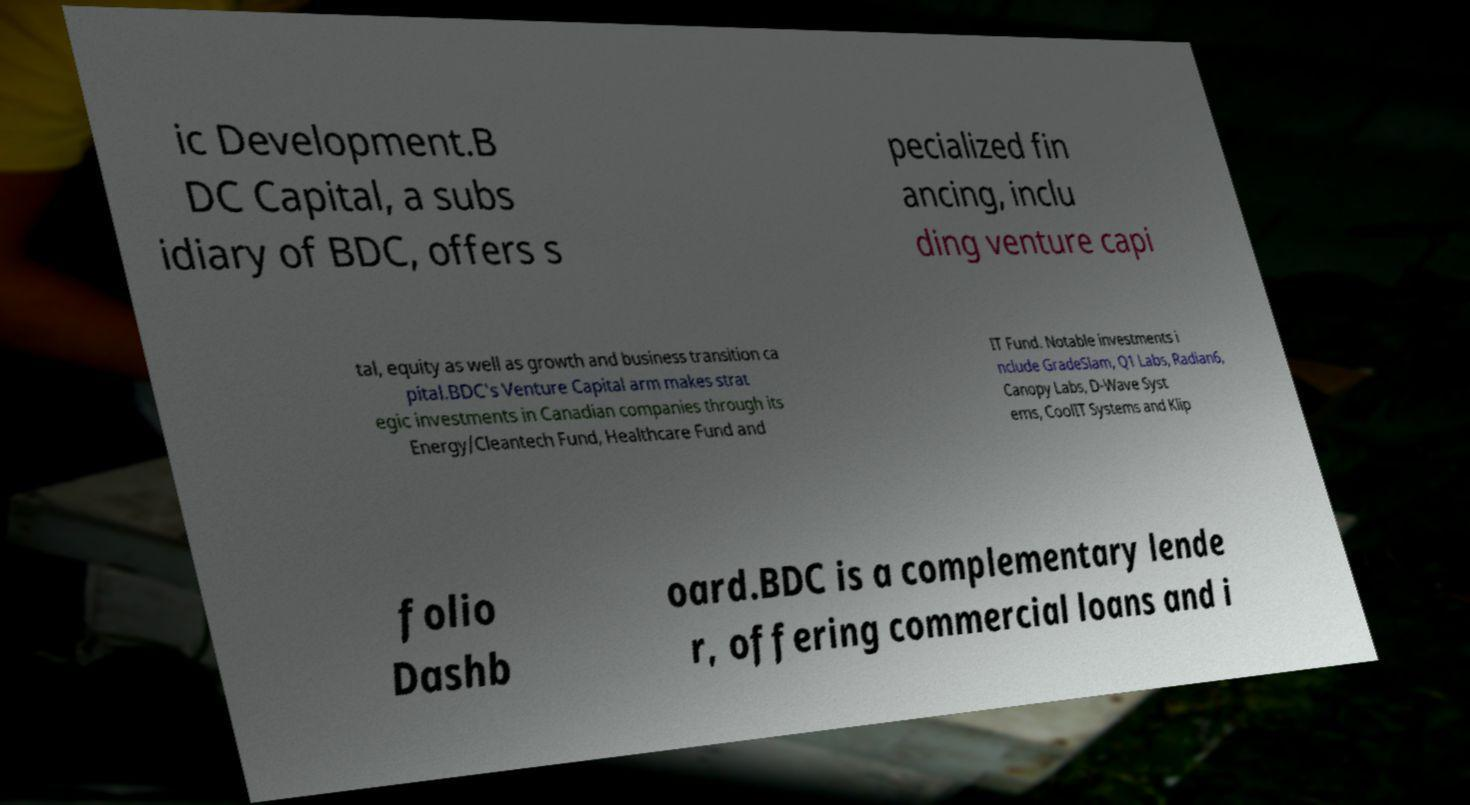There's text embedded in this image that I need extracted. Can you transcribe it verbatim? ic Development.B DC Capital, a subs idiary of BDC, offers s pecialized fin ancing, inclu ding venture capi tal, equity as well as growth and business transition ca pital.BDC's Venture Capital arm makes strat egic investments in Canadian companies through its Energy/Cleantech Fund, Healthcare Fund and IT Fund. Notable investments i nclude GradeSlam, Q1 Labs, Radian6, Canopy Labs, D-Wave Syst ems, CoolIT Systems and Klip folio Dashb oard.BDC is a complementary lende r, offering commercial loans and i 